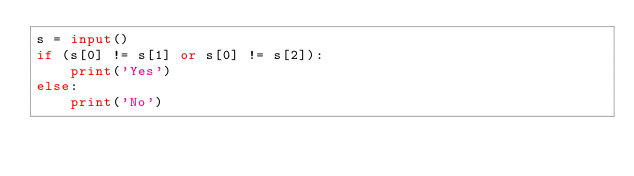Convert code to text. <code><loc_0><loc_0><loc_500><loc_500><_Python_>s = input()
if (s[0] != s[1] or s[0] != s[2]):
    print('Yes')
else:
    print('No')</code> 